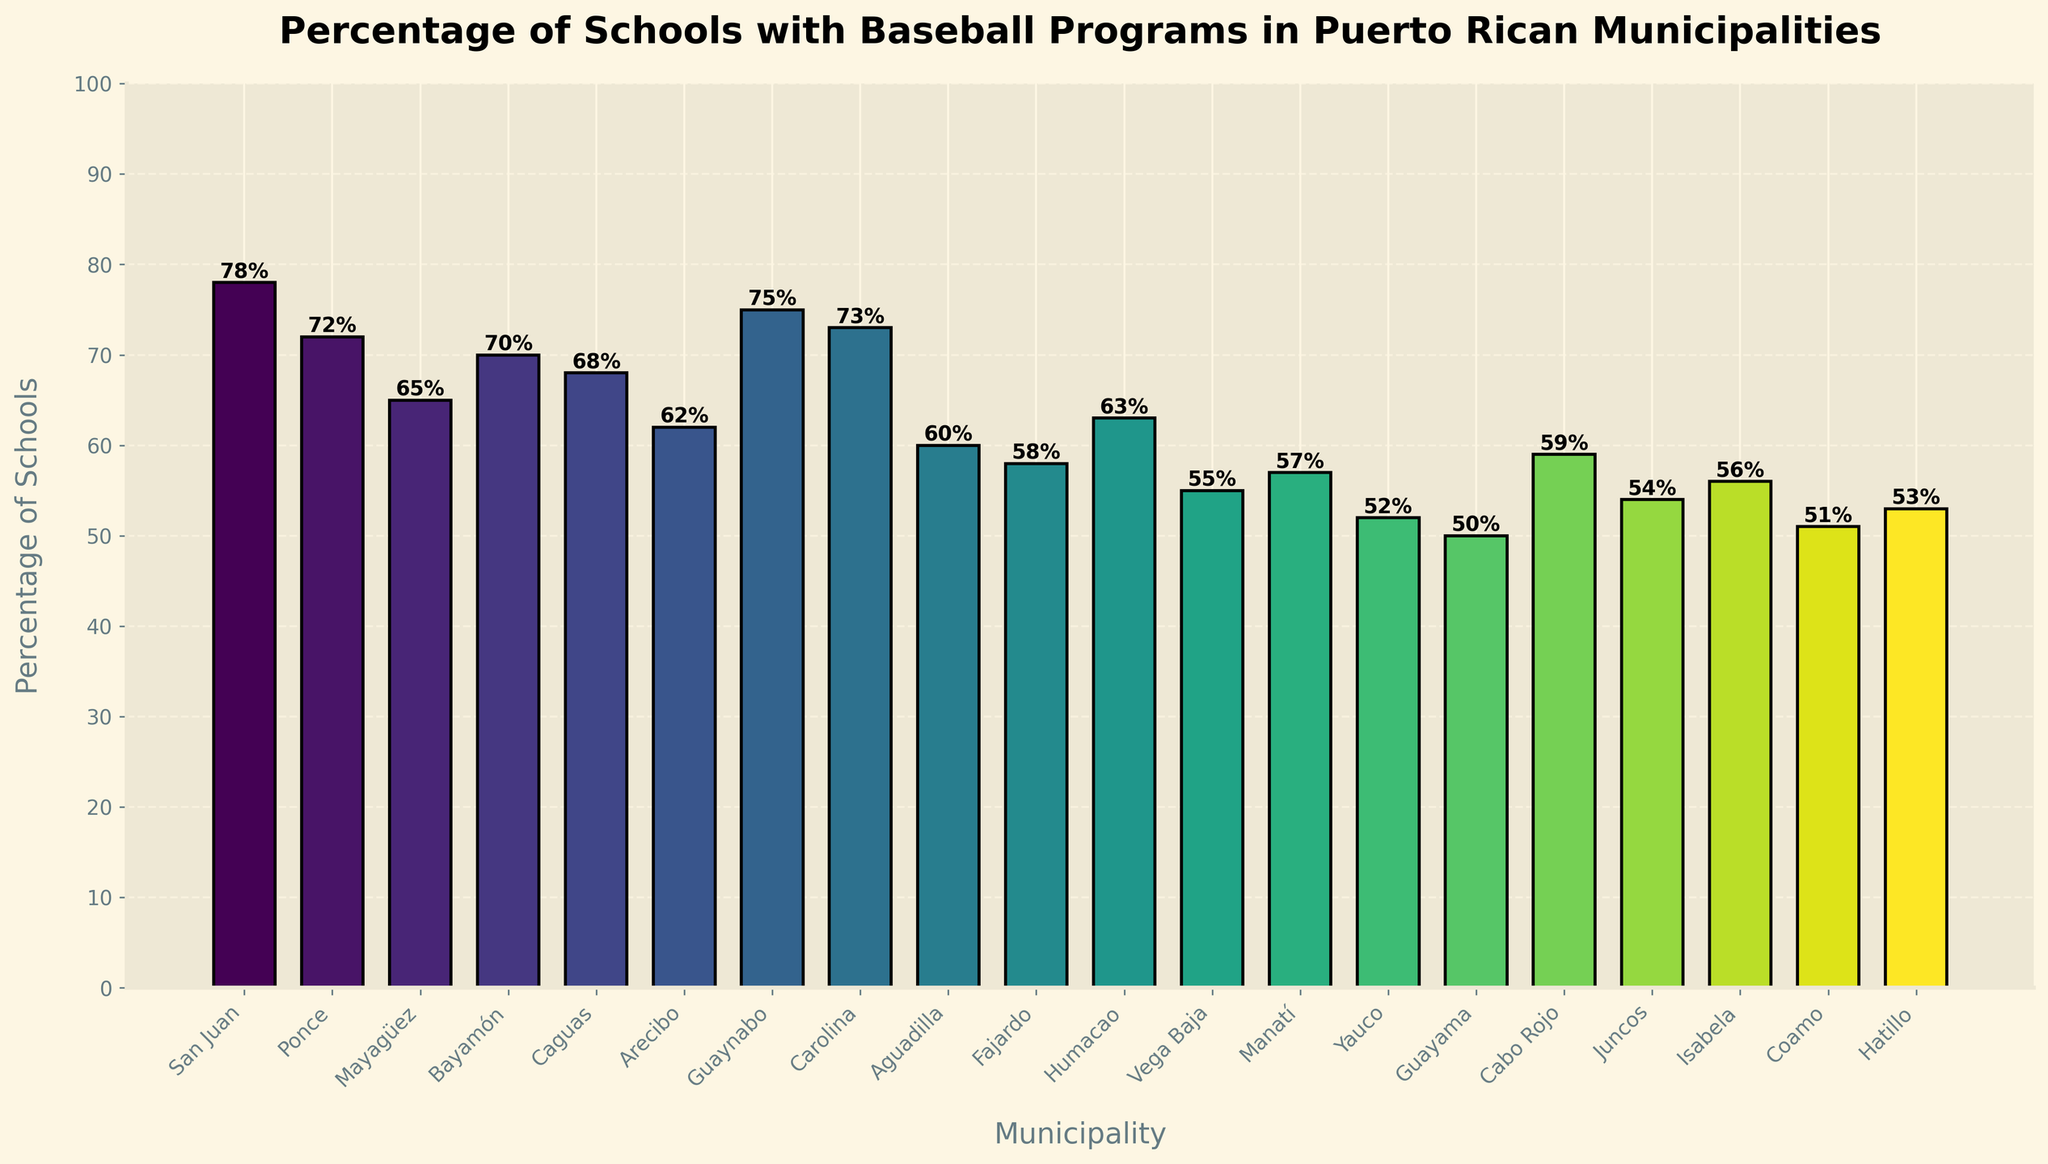What's the percentage of schools with baseball programs in San Juan? By observing the bar labeled 'San Juan', we can see its height and the percentage value displayed on top of the bar.
Answer: 78% Which municipality has the lowest percentage of schools with baseball programs? By comparing the heights of all bars, the shortest bar represents 'Guayama', and the percentage value above it confirms it has the lowest percentage.
Answer: Guayama How much higher is the percentage of schools with baseball programs in Guaynabo compared to Fajardo? First, find the percentage for Guaynabo (75%) and Fajardo (58%). Calculate the difference: 75% - 58% = 17%.
Answer: 17% Which two municipalities have the same percentage of schools with baseball programs? Examine the height and percentage labels of each bar. 'Humacao' and 'Arecibo' both have the same height and percentage value of 63%.
Answer: Humacao and Arecibo What is the average percentage of schools with baseball programs in the municipalities where the percentage is over 70%? Identify municipalities with over 70%: San Juan (78%), Ponce (72%), Guaynabo (75%), Carolina (73%), Bayamón (70%). Sum these percentages together: 78 + 72 + 75 + 73 + 70 = 368. Divide by the number of municipalities (5). 368 / 5 = 73.6%.
Answer: 73.6% Which municipality has the highest percentage of schools with baseball programs, and what is that percentage? Identify the tallest bar in the chart, which corresponds to 'San Juan', and the percentage on top of the bar is 78%.
Answer: San Juan, 78% How does the percentage of schools with baseball programs in Mayagüez compare to Vega Baja? Find the percentages for Mayagüez (65%) and Vega Baja (55%) and compare them. Mayagüez has a higher percentage than Vega Baja.
Answer: Mayagüez has a higher percentage What's the median value of the percentages for all municipalities? List the percentages in ascending order: 50, 51, 52, 53, 54, 55, 56, 57, 58, 59, 60, 62, 63, 65, 68, 70, 72, 73, 75, 78. The median value is the middle value here, which is the 10th and 11th values averaged: (59 + 60) / 2 = 59.5%.
Answer: 59.5% What is the total number of municipalities with more than 60% of schools with baseball programs? Count the bars with percentage values above 60%. These bars belong to San Juan, Ponce, Mayagüez, Bayamón, Caguas, Arecibo, Guaynabo, Carolina, Humacao, Cabo Rojo. There are 10 such municipalities.
Answer: 10 